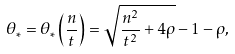Convert formula to latex. <formula><loc_0><loc_0><loc_500><loc_500>\theta _ { \ast } = \theta _ { \ast } \left ( \frac { n } { t } \right ) = \sqrt { \frac { n ^ { 2 } } { t ^ { 2 } } + 4 \rho } - 1 - \rho ,</formula> 